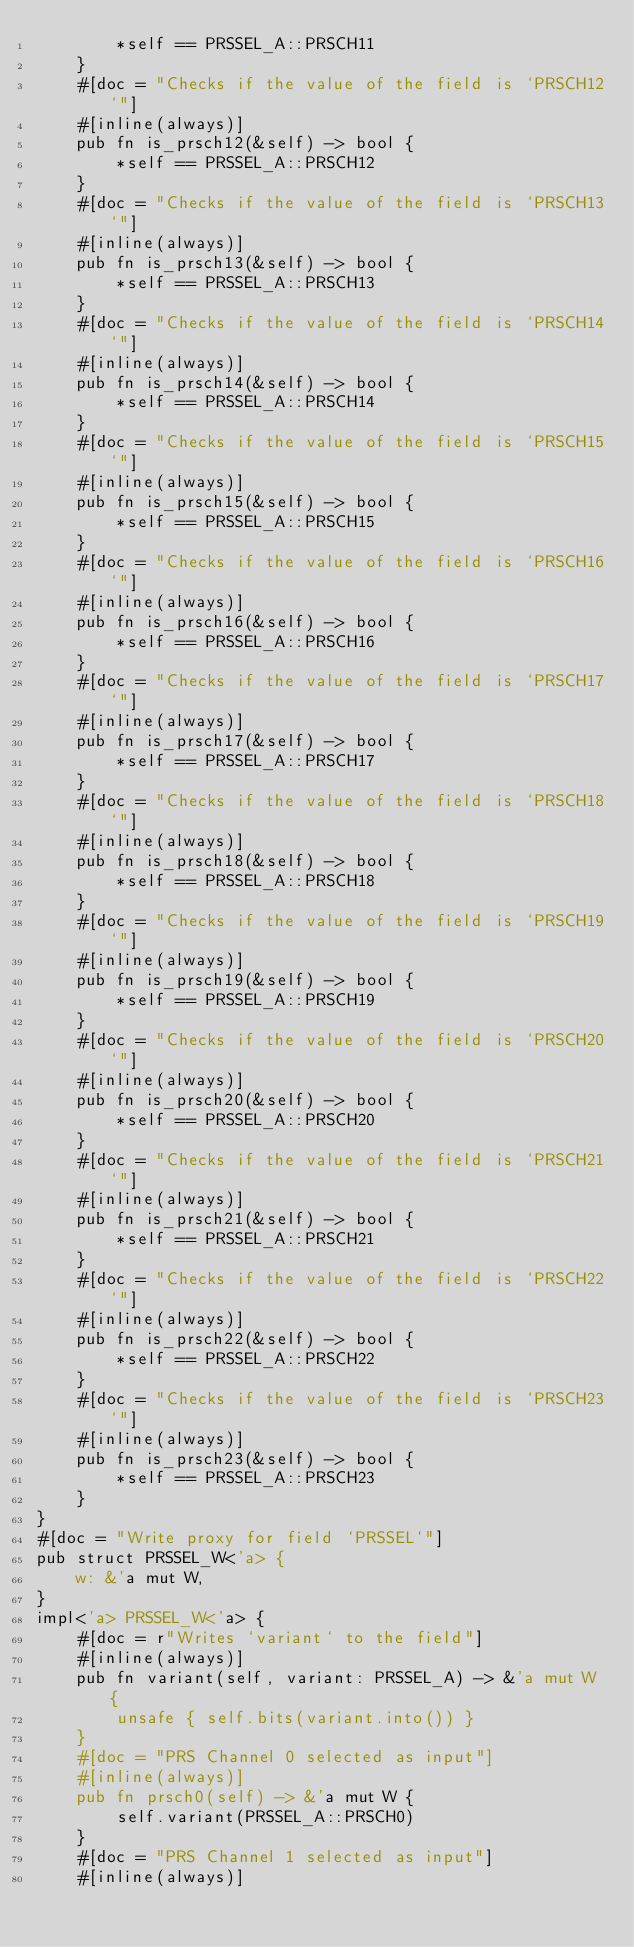Convert code to text. <code><loc_0><loc_0><loc_500><loc_500><_Rust_>        *self == PRSSEL_A::PRSCH11
    }
    #[doc = "Checks if the value of the field is `PRSCH12`"]
    #[inline(always)]
    pub fn is_prsch12(&self) -> bool {
        *self == PRSSEL_A::PRSCH12
    }
    #[doc = "Checks if the value of the field is `PRSCH13`"]
    #[inline(always)]
    pub fn is_prsch13(&self) -> bool {
        *self == PRSSEL_A::PRSCH13
    }
    #[doc = "Checks if the value of the field is `PRSCH14`"]
    #[inline(always)]
    pub fn is_prsch14(&self) -> bool {
        *self == PRSSEL_A::PRSCH14
    }
    #[doc = "Checks if the value of the field is `PRSCH15`"]
    #[inline(always)]
    pub fn is_prsch15(&self) -> bool {
        *self == PRSSEL_A::PRSCH15
    }
    #[doc = "Checks if the value of the field is `PRSCH16`"]
    #[inline(always)]
    pub fn is_prsch16(&self) -> bool {
        *self == PRSSEL_A::PRSCH16
    }
    #[doc = "Checks if the value of the field is `PRSCH17`"]
    #[inline(always)]
    pub fn is_prsch17(&self) -> bool {
        *self == PRSSEL_A::PRSCH17
    }
    #[doc = "Checks if the value of the field is `PRSCH18`"]
    #[inline(always)]
    pub fn is_prsch18(&self) -> bool {
        *self == PRSSEL_A::PRSCH18
    }
    #[doc = "Checks if the value of the field is `PRSCH19`"]
    #[inline(always)]
    pub fn is_prsch19(&self) -> bool {
        *self == PRSSEL_A::PRSCH19
    }
    #[doc = "Checks if the value of the field is `PRSCH20`"]
    #[inline(always)]
    pub fn is_prsch20(&self) -> bool {
        *self == PRSSEL_A::PRSCH20
    }
    #[doc = "Checks if the value of the field is `PRSCH21`"]
    #[inline(always)]
    pub fn is_prsch21(&self) -> bool {
        *self == PRSSEL_A::PRSCH21
    }
    #[doc = "Checks if the value of the field is `PRSCH22`"]
    #[inline(always)]
    pub fn is_prsch22(&self) -> bool {
        *self == PRSSEL_A::PRSCH22
    }
    #[doc = "Checks if the value of the field is `PRSCH23`"]
    #[inline(always)]
    pub fn is_prsch23(&self) -> bool {
        *self == PRSSEL_A::PRSCH23
    }
}
#[doc = "Write proxy for field `PRSSEL`"]
pub struct PRSSEL_W<'a> {
    w: &'a mut W,
}
impl<'a> PRSSEL_W<'a> {
    #[doc = r"Writes `variant` to the field"]
    #[inline(always)]
    pub fn variant(self, variant: PRSSEL_A) -> &'a mut W {
        unsafe { self.bits(variant.into()) }
    }
    #[doc = "PRS Channel 0 selected as input"]
    #[inline(always)]
    pub fn prsch0(self) -> &'a mut W {
        self.variant(PRSSEL_A::PRSCH0)
    }
    #[doc = "PRS Channel 1 selected as input"]
    #[inline(always)]</code> 